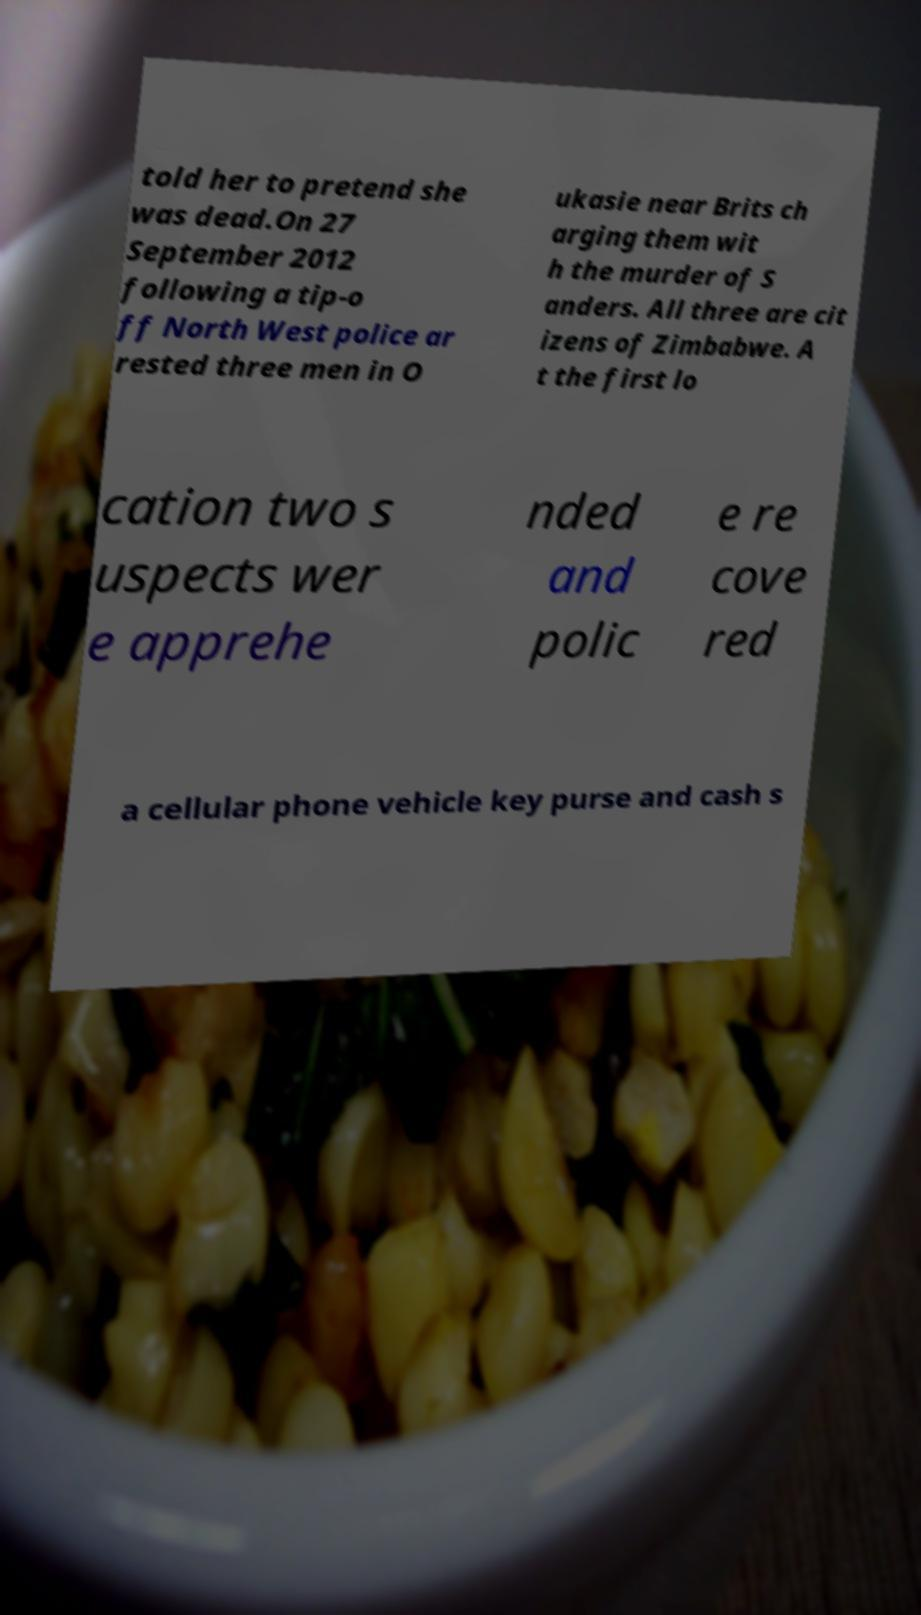Could you assist in decoding the text presented in this image and type it out clearly? told her to pretend she was dead.On 27 September 2012 following a tip-o ff North West police ar rested three men in O ukasie near Brits ch arging them wit h the murder of S anders. All three are cit izens of Zimbabwe. A t the first lo cation two s uspects wer e apprehe nded and polic e re cove red a cellular phone vehicle key purse and cash s 